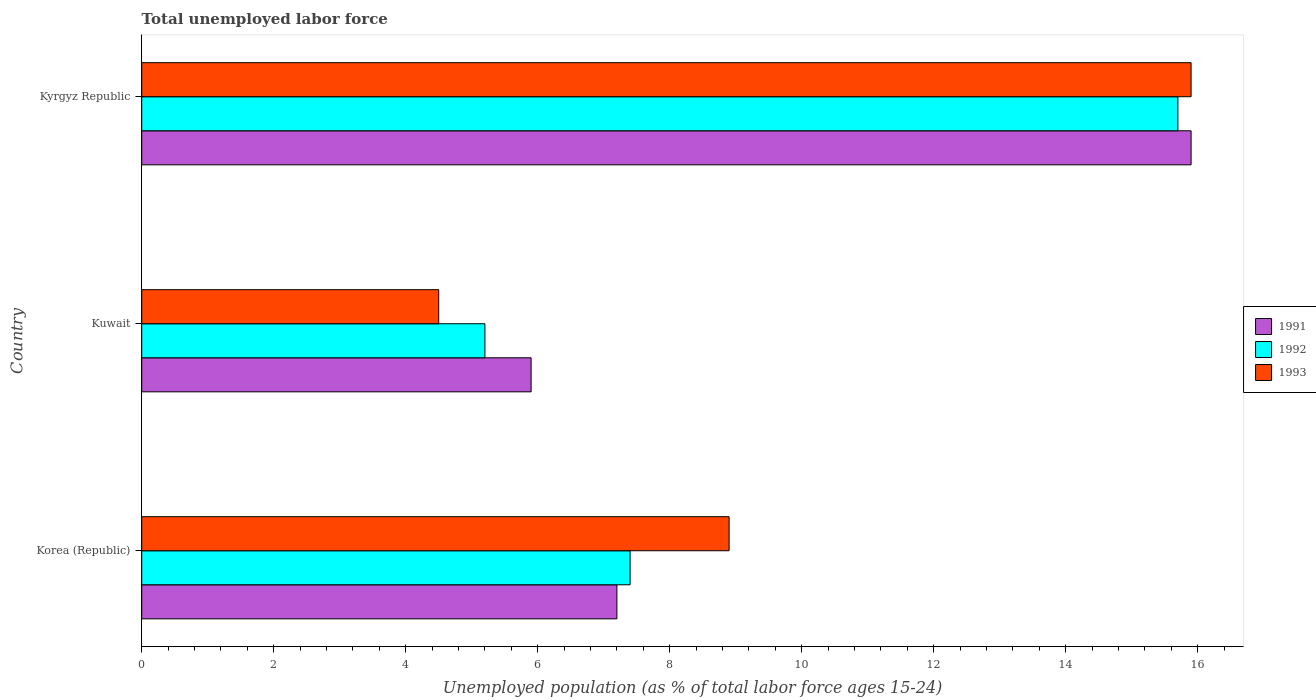How many groups of bars are there?
Keep it short and to the point. 3. Are the number of bars on each tick of the Y-axis equal?
Keep it short and to the point. Yes. How many bars are there on the 1st tick from the top?
Offer a very short reply. 3. How many bars are there on the 1st tick from the bottom?
Keep it short and to the point. 3. What is the label of the 3rd group of bars from the top?
Offer a terse response. Korea (Republic). What is the percentage of unemployed population in in 1991 in Kuwait?
Provide a succinct answer. 5.9. Across all countries, what is the maximum percentage of unemployed population in in 1991?
Offer a terse response. 15.9. Across all countries, what is the minimum percentage of unemployed population in in 1992?
Your response must be concise. 5.2. In which country was the percentage of unemployed population in in 1993 maximum?
Your answer should be compact. Kyrgyz Republic. In which country was the percentage of unemployed population in in 1993 minimum?
Ensure brevity in your answer.  Kuwait. What is the total percentage of unemployed population in in 1993 in the graph?
Give a very brief answer. 29.3. What is the difference between the percentage of unemployed population in in 1991 in Korea (Republic) and that in Kuwait?
Keep it short and to the point. 1.3. What is the difference between the percentage of unemployed population in in 1993 in Kuwait and the percentage of unemployed population in in 1992 in Kyrgyz Republic?
Make the answer very short. -11.2. What is the average percentage of unemployed population in in 1991 per country?
Keep it short and to the point. 9.67. What is the difference between the percentage of unemployed population in in 1993 and percentage of unemployed population in in 1992 in Kyrgyz Republic?
Keep it short and to the point. 0.2. What is the ratio of the percentage of unemployed population in in 1991 in Korea (Republic) to that in Kyrgyz Republic?
Provide a succinct answer. 0.45. What is the difference between the highest and the second highest percentage of unemployed population in in 1992?
Ensure brevity in your answer.  8.3. What is the difference between the highest and the lowest percentage of unemployed population in in 1993?
Make the answer very short. 11.4. In how many countries, is the percentage of unemployed population in in 1992 greater than the average percentage of unemployed population in in 1992 taken over all countries?
Your response must be concise. 1. Is the sum of the percentage of unemployed population in in 1991 in Korea (Republic) and Kuwait greater than the maximum percentage of unemployed population in in 1993 across all countries?
Your response must be concise. No. What does the 1st bar from the top in Kyrgyz Republic represents?
Ensure brevity in your answer.  1993. What does the 3rd bar from the bottom in Korea (Republic) represents?
Your answer should be very brief. 1993. Is it the case that in every country, the sum of the percentage of unemployed population in in 1992 and percentage of unemployed population in in 1993 is greater than the percentage of unemployed population in in 1991?
Ensure brevity in your answer.  Yes. Are all the bars in the graph horizontal?
Provide a short and direct response. Yes. How many countries are there in the graph?
Keep it short and to the point. 3. Are the values on the major ticks of X-axis written in scientific E-notation?
Provide a short and direct response. No. Does the graph contain grids?
Offer a terse response. No. Where does the legend appear in the graph?
Offer a very short reply. Center right. How are the legend labels stacked?
Provide a succinct answer. Vertical. What is the title of the graph?
Your answer should be very brief. Total unemployed labor force. What is the label or title of the X-axis?
Your answer should be compact. Unemployed population (as % of total labor force ages 15-24). What is the Unemployed population (as % of total labor force ages 15-24) in 1991 in Korea (Republic)?
Your response must be concise. 7.2. What is the Unemployed population (as % of total labor force ages 15-24) in 1992 in Korea (Republic)?
Ensure brevity in your answer.  7.4. What is the Unemployed population (as % of total labor force ages 15-24) in 1993 in Korea (Republic)?
Give a very brief answer. 8.9. What is the Unemployed population (as % of total labor force ages 15-24) of 1991 in Kuwait?
Make the answer very short. 5.9. What is the Unemployed population (as % of total labor force ages 15-24) of 1992 in Kuwait?
Offer a terse response. 5.2. What is the Unemployed population (as % of total labor force ages 15-24) in 1991 in Kyrgyz Republic?
Your response must be concise. 15.9. What is the Unemployed population (as % of total labor force ages 15-24) in 1992 in Kyrgyz Republic?
Your answer should be very brief. 15.7. What is the Unemployed population (as % of total labor force ages 15-24) of 1993 in Kyrgyz Republic?
Your answer should be compact. 15.9. Across all countries, what is the maximum Unemployed population (as % of total labor force ages 15-24) in 1991?
Your response must be concise. 15.9. Across all countries, what is the maximum Unemployed population (as % of total labor force ages 15-24) of 1992?
Make the answer very short. 15.7. Across all countries, what is the maximum Unemployed population (as % of total labor force ages 15-24) in 1993?
Make the answer very short. 15.9. Across all countries, what is the minimum Unemployed population (as % of total labor force ages 15-24) of 1991?
Your answer should be very brief. 5.9. Across all countries, what is the minimum Unemployed population (as % of total labor force ages 15-24) of 1992?
Offer a terse response. 5.2. What is the total Unemployed population (as % of total labor force ages 15-24) in 1991 in the graph?
Keep it short and to the point. 29. What is the total Unemployed population (as % of total labor force ages 15-24) in 1992 in the graph?
Your answer should be compact. 28.3. What is the total Unemployed population (as % of total labor force ages 15-24) of 1993 in the graph?
Offer a terse response. 29.3. What is the difference between the Unemployed population (as % of total labor force ages 15-24) of 1992 in Korea (Republic) and that in Kuwait?
Ensure brevity in your answer.  2.2. What is the difference between the Unemployed population (as % of total labor force ages 15-24) of 1993 in Korea (Republic) and that in Kuwait?
Keep it short and to the point. 4.4. What is the difference between the Unemployed population (as % of total labor force ages 15-24) in 1992 in Korea (Republic) and that in Kyrgyz Republic?
Offer a terse response. -8.3. What is the difference between the Unemployed population (as % of total labor force ages 15-24) in 1991 in Kuwait and that in Kyrgyz Republic?
Ensure brevity in your answer.  -10. What is the difference between the Unemployed population (as % of total labor force ages 15-24) in 1991 in Korea (Republic) and the Unemployed population (as % of total labor force ages 15-24) in 1992 in Kuwait?
Your response must be concise. 2. What is the difference between the Unemployed population (as % of total labor force ages 15-24) of 1991 in Korea (Republic) and the Unemployed population (as % of total labor force ages 15-24) of 1993 in Kuwait?
Ensure brevity in your answer.  2.7. What is the difference between the Unemployed population (as % of total labor force ages 15-24) in 1991 in Korea (Republic) and the Unemployed population (as % of total labor force ages 15-24) in 1992 in Kyrgyz Republic?
Offer a very short reply. -8.5. What is the difference between the Unemployed population (as % of total labor force ages 15-24) of 1992 in Korea (Republic) and the Unemployed population (as % of total labor force ages 15-24) of 1993 in Kyrgyz Republic?
Keep it short and to the point. -8.5. What is the difference between the Unemployed population (as % of total labor force ages 15-24) in 1991 in Kuwait and the Unemployed population (as % of total labor force ages 15-24) in 1992 in Kyrgyz Republic?
Give a very brief answer. -9.8. What is the difference between the Unemployed population (as % of total labor force ages 15-24) of 1991 in Kuwait and the Unemployed population (as % of total labor force ages 15-24) of 1993 in Kyrgyz Republic?
Keep it short and to the point. -10. What is the difference between the Unemployed population (as % of total labor force ages 15-24) in 1992 in Kuwait and the Unemployed population (as % of total labor force ages 15-24) in 1993 in Kyrgyz Republic?
Ensure brevity in your answer.  -10.7. What is the average Unemployed population (as % of total labor force ages 15-24) in 1991 per country?
Offer a very short reply. 9.67. What is the average Unemployed population (as % of total labor force ages 15-24) in 1992 per country?
Make the answer very short. 9.43. What is the average Unemployed population (as % of total labor force ages 15-24) of 1993 per country?
Make the answer very short. 9.77. What is the difference between the Unemployed population (as % of total labor force ages 15-24) in 1991 and Unemployed population (as % of total labor force ages 15-24) in 1992 in Korea (Republic)?
Offer a very short reply. -0.2. What is the difference between the Unemployed population (as % of total labor force ages 15-24) of 1991 and Unemployed population (as % of total labor force ages 15-24) of 1993 in Korea (Republic)?
Provide a succinct answer. -1.7. What is the difference between the Unemployed population (as % of total labor force ages 15-24) in 1991 and Unemployed population (as % of total labor force ages 15-24) in 1992 in Kuwait?
Provide a short and direct response. 0.7. What is the difference between the Unemployed population (as % of total labor force ages 15-24) in 1991 and Unemployed population (as % of total labor force ages 15-24) in 1993 in Kuwait?
Keep it short and to the point. 1.4. What is the difference between the Unemployed population (as % of total labor force ages 15-24) in 1992 and Unemployed population (as % of total labor force ages 15-24) in 1993 in Kuwait?
Your response must be concise. 0.7. What is the difference between the Unemployed population (as % of total labor force ages 15-24) of 1992 and Unemployed population (as % of total labor force ages 15-24) of 1993 in Kyrgyz Republic?
Your answer should be very brief. -0.2. What is the ratio of the Unemployed population (as % of total labor force ages 15-24) of 1991 in Korea (Republic) to that in Kuwait?
Give a very brief answer. 1.22. What is the ratio of the Unemployed population (as % of total labor force ages 15-24) in 1992 in Korea (Republic) to that in Kuwait?
Your answer should be compact. 1.42. What is the ratio of the Unemployed population (as % of total labor force ages 15-24) in 1993 in Korea (Republic) to that in Kuwait?
Provide a succinct answer. 1.98. What is the ratio of the Unemployed population (as % of total labor force ages 15-24) in 1991 in Korea (Republic) to that in Kyrgyz Republic?
Your response must be concise. 0.45. What is the ratio of the Unemployed population (as % of total labor force ages 15-24) of 1992 in Korea (Republic) to that in Kyrgyz Republic?
Offer a very short reply. 0.47. What is the ratio of the Unemployed population (as % of total labor force ages 15-24) of 1993 in Korea (Republic) to that in Kyrgyz Republic?
Your answer should be compact. 0.56. What is the ratio of the Unemployed population (as % of total labor force ages 15-24) in 1991 in Kuwait to that in Kyrgyz Republic?
Give a very brief answer. 0.37. What is the ratio of the Unemployed population (as % of total labor force ages 15-24) in 1992 in Kuwait to that in Kyrgyz Republic?
Ensure brevity in your answer.  0.33. What is the ratio of the Unemployed population (as % of total labor force ages 15-24) in 1993 in Kuwait to that in Kyrgyz Republic?
Your response must be concise. 0.28. What is the difference between the highest and the second highest Unemployed population (as % of total labor force ages 15-24) of 1991?
Your response must be concise. 8.7. What is the difference between the highest and the second highest Unemployed population (as % of total labor force ages 15-24) of 1992?
Provide a succinct answer. 8.3. What is the difference between the highest and the second highest Unemployed population (as % of total labor force ages 15-24) of 1993?
Offer a very short reply. 7. What is the difference between the highest and the lowest Unemployed population (as % of total labor force ages 15-24) of 1992?
Give a very brief answer. 10.5. What is the difference between the highest and the lowest Unemployed population (as % of total labor force ages 15-24) in 1993?
Provide a short and direct response. 11.4. 